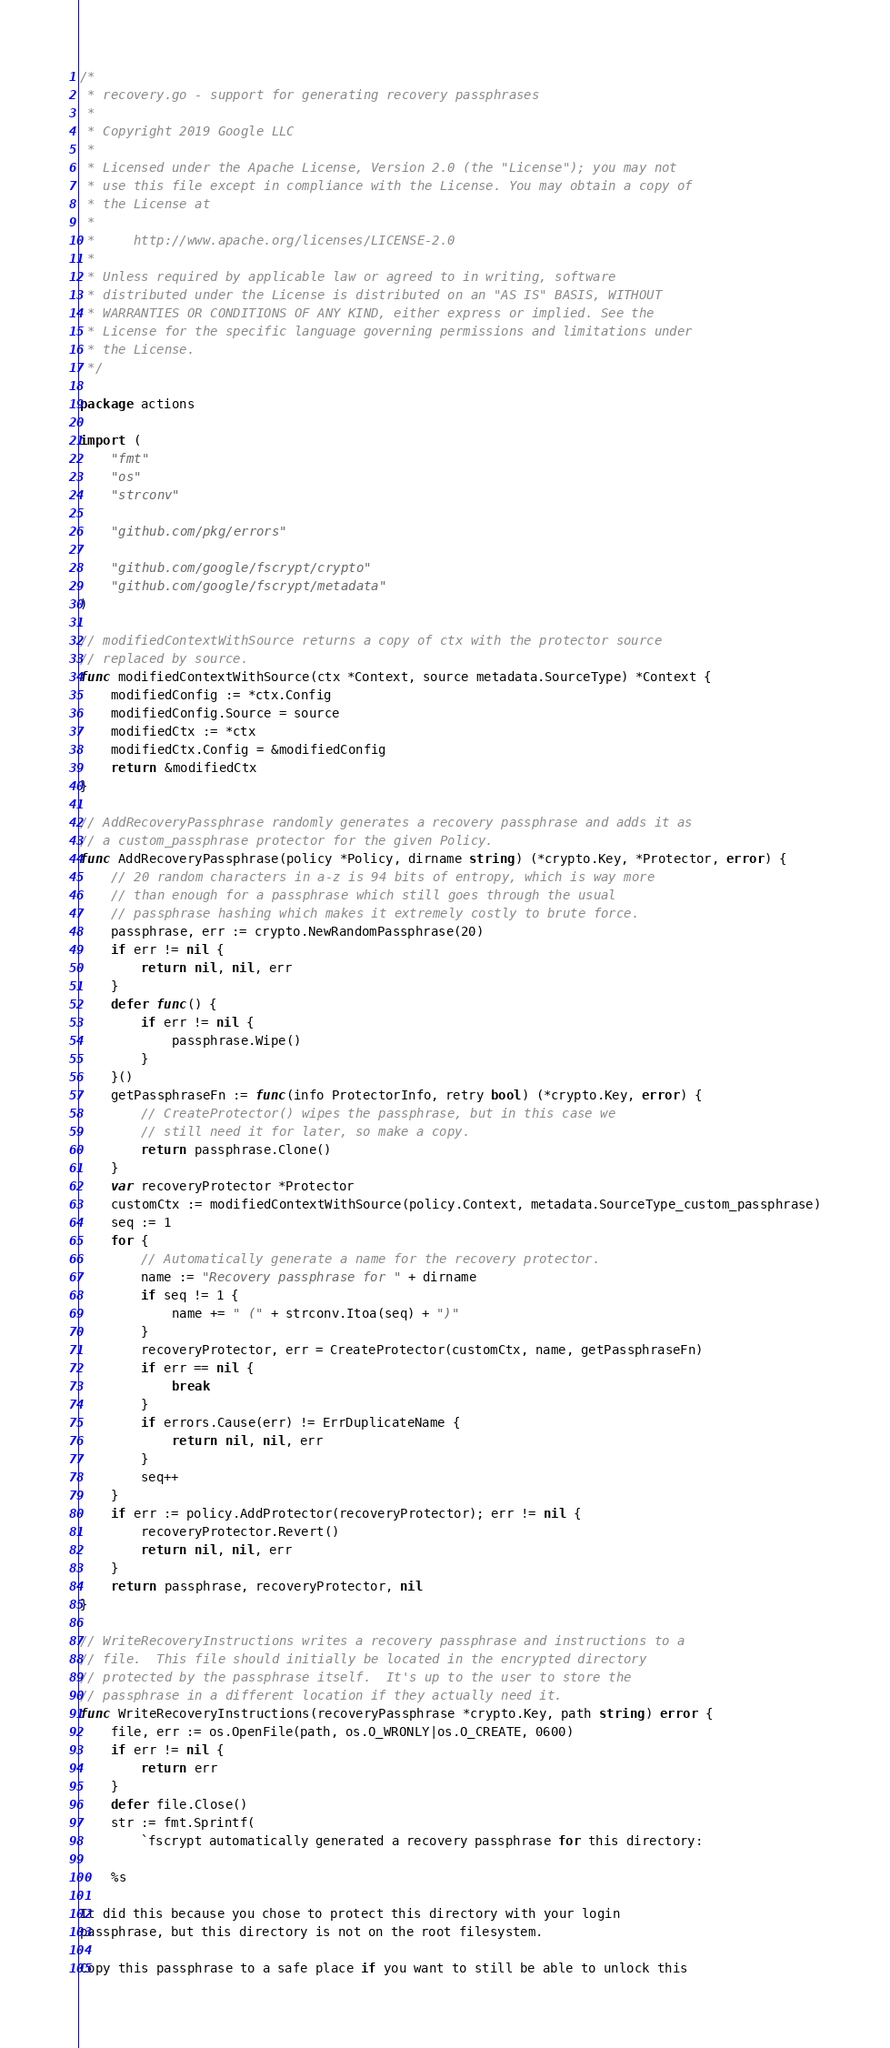<code> <loc_0><loc_0><loc_500><loc_500><_Go_>/*
 * recovery.go - support for generating recovery passphrases
 *
 * Copyright 2019 Google LLC
 *
 * Licensed under the Apache License, Version 2.0 (the "License"); you may not
 * use this file except in compliance with the License. You may obtain a copy of
 * the License at
 *
 *     http://www.apache.org/licenses/LICENSE-2.0
 *
 * Unless required by applicable law or agreed to in writing, software
 * distributed under the License is distributed on an "AS IS" BASIS, WITHOUT
 * WARRANTIES OR CONDITIONS OF ANY KIND, either express or implied. See the
 * License for the specific language governing permissions and limitations under
 * the License.
 */

package actions

import (
	"fmt"
	"os"
	"strconv"

	"github.com/pkg/errors"

	"github.com/google/fscrypt/crypto"
	"github.com/google/fscrypt/metadata"
)

// modifiedContextWithSource returns a copy of ctx with the protector source
// replaced by source.
func modifiedContextWithSource(ctx *Context, source metadata.SourceType) *Context {
	modifiedConfig := *ctx.Config
	modifiedConfig.Source = source
	modifiedCtx := *ctx
	modifiedCtx.Config = &modifiedConfig
	return &modifiedCtx
}

// AddRecoveryPassphrase randomly generates a recovery passphrase and adds it as
// a custom_passphrase protector for the given Policy.
func AddRecoveryPassphrase(policy *Policy, dirname string) (*crypto.Key, *Protector, error) {
	// 20 random characters in a-z is 94 bits of entropy, which is way more
	// than enough for a passphrase which still goes through the usual
	// passphrase hashing which makes it extremely costly to brute force.
	passphrase, err := crypto.NewRandomPassphrase(20)
	if err != nil {
		return nil, nil, err
	}
	defer func() {
		if err != nil {
			passphrase.Wipe()
		}
	}()
	getPassphraseFn := func(info ProtectorInfo, retry bool) (*crypto.Key, error) {
		// CreateProtector() wipes the passphrase, but in this case we
		// still need it for later, so make a copy.
		return passphrase.Clone()
	}
	var recoveryProtector *Protector
	customCtx := modifiedContextWithSource(policy.Context, metadata.SourceType_custom_passphrase)
	seq := 1
	for {
		// Automatically generate a name for the recovery protector.
		name := "Recovery passphrase for " + dirname
		if seq != 1 {
			name += " (" + strconv.Itoa(seq) + ")"
		}
		recoveryProtector, err = CreateProtector(customCtx, name, getPassphraseFn)
		if err == nil {
			break
		}
		if errors.Cause(err) != ErrDuplicateName {
			return nil, nil, err
		}
		seq++
	}
	if err := policy.AddProtector(recoveryProtector); err != nil {
		recoveryProtector.Revert()
		return nil, nil, err
	}
	return passphrase, recoveryProtector, nil
}

// WriteRecoveryInstructions writes a recovery passphrase and instructions to a
// file.  This file should initially be located in the encrypted directory
// protected by the passphrase itself.  It's up to the user to store the
// passphrase in a different location if they actually need it.
func WriteRecoveryInstructions(recoveryPassphrase *crypto.Key, path string) error {
	file, err := os.OpenFile(path, os.O_WRONLY|os.O_CREATE, 0600)
	if err != nil {
		return err
	}
	defer file.Close()
	str := fmt.Sprintf(
		`fscrypt automatically generated a recovery passphrase for this directory:

    %s

It did this because you chose to protect this directory with your login
passphrase, but this directory is not on the root filesystem.

Copy this passphrase to a safe place if you want to still be able to unlock this</code> 